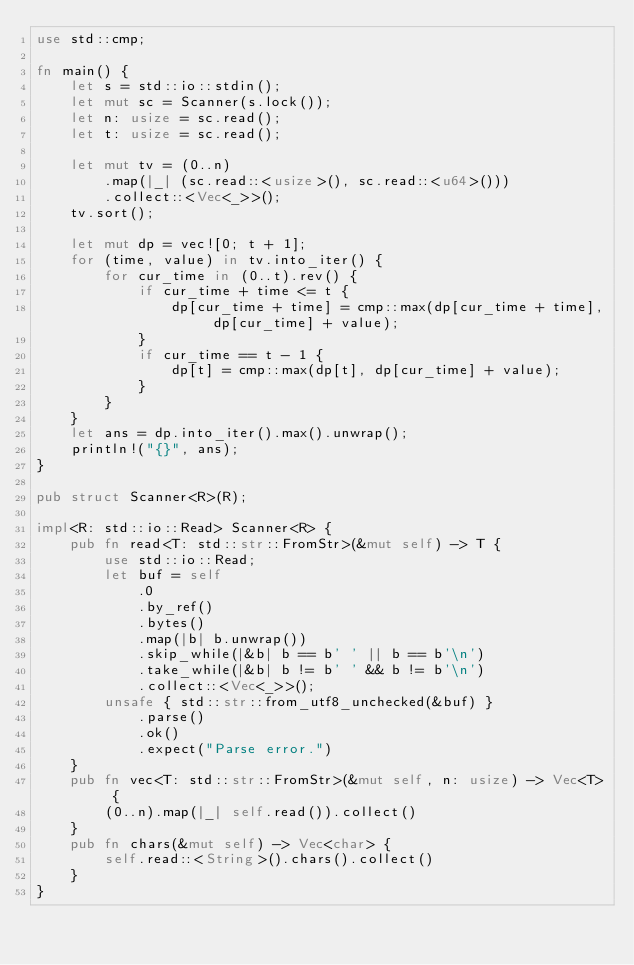<code> <loc_0><loc_0><loc_500><loc_500><_Rust_>use std::cmp;

fn main() {
    let s = std::io::stdin();
    let mut sc = Scanner(s.lock());
    let n: usize = sc.read();
    let t: usize = sc.read();

    let mut tv = (0..n)
        .map(|_| (sc.read::<usize>(), sc.read::<u64>()))
        .collect::<Vec<_>>();
    tv.sort();

    let mut dp = vec![0; t + 1];
    for (time, value) in tv.into_iter() {
        for cur_time in (0..t).rev() {
            if cur_time + time <= t {
                dp[cur_time + time] = cmp::max(dp[cur_time + time], dp[cur_time] + value);
            }
            if cur_time == t - 1 {
                dp[t] = cmp::max(dp[t], dp[cur_time] + value);
            }
        }
    }
    let ans = dp.into_iter().max().unwrap();
    println!("{}", ans);
}

pub struct Scanner<R>(R);

impl<R: std::io::Read> Scanner<R> {
    pub fn read<T: std::str::FromStr>(&mut self) -> T {
        use std::io::Read;
        let buf = self
            .0
            .by_ref()
            .bytes()
            .map(|b| b.unwrap())
            .skip_while(|&b| b == b' ' || b == b'\n')
            .take_while(|&b| b != b' ' && b != b'\n')
            .collect::<Vec<_>>();
        unsafe { std::str::from_utf8_unchecked(&buf) }
            .parse()
            .ok()
            .expect("Parse error.")
    }
    pub fn vec<T: std::str::FromStr>(&mut self, n: usize) -> Vec<T> {
        (0..n).map(|_| self.read()).collect()
    }
    pub fn chars(&mut self) -> Vec<char> {
        self.read::<String>().chars().collect()
    }
}
</code> 